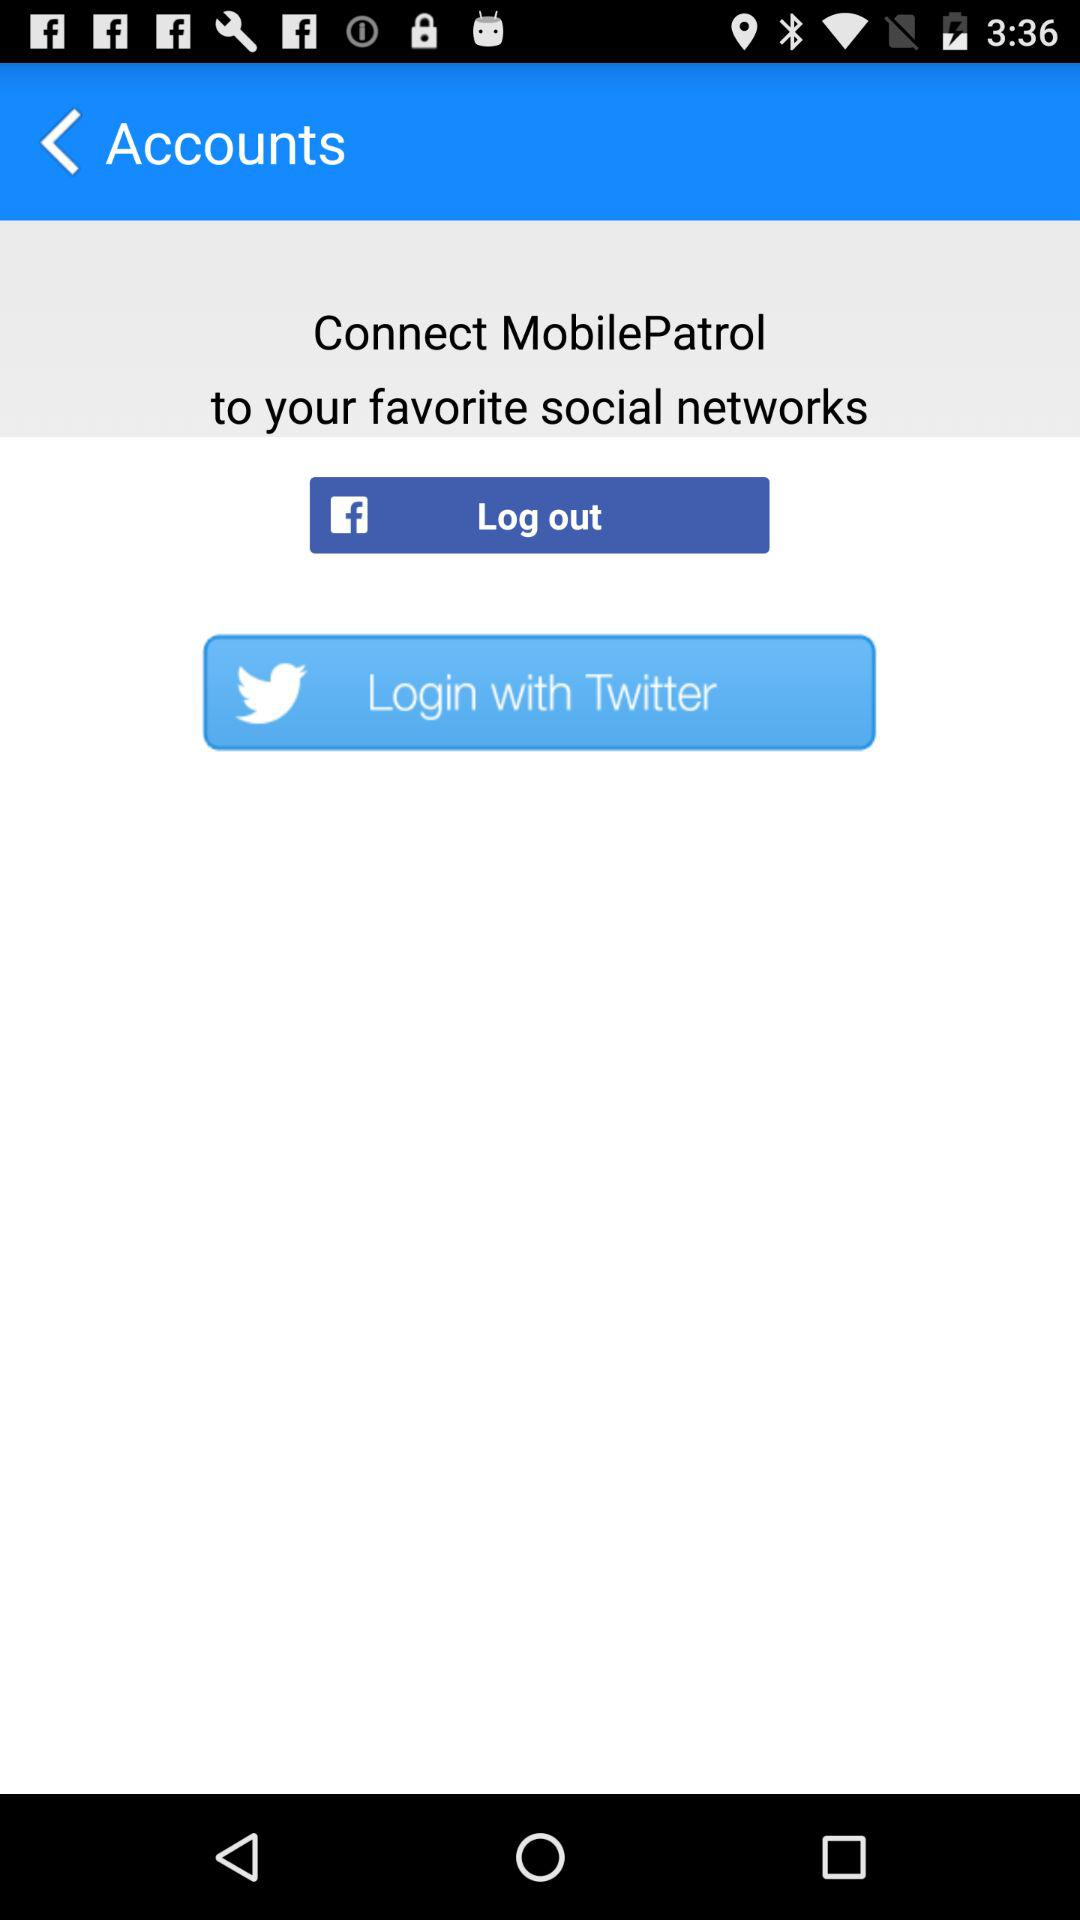What account can be used to log in? The account that can be used to log in is "Twitter". 